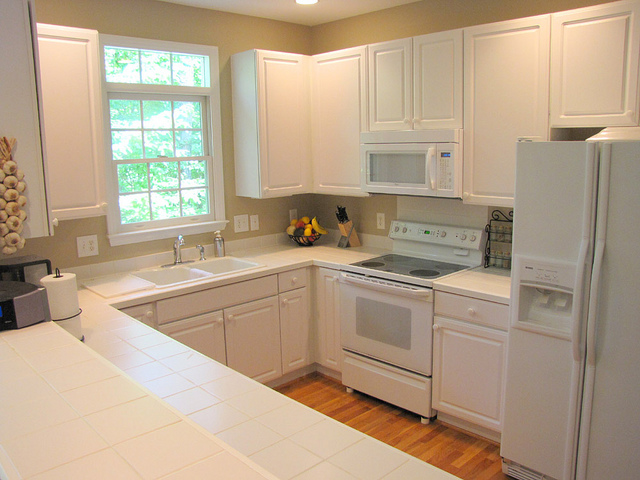<image>Are the fruits in the basket real or wax? I don't know if the fruits in the basket are real or wax. It is not clear. Are the fruits in the basket real or wax? I don't know if the fruits in the basket are real or wax. It is not clear from the image. 